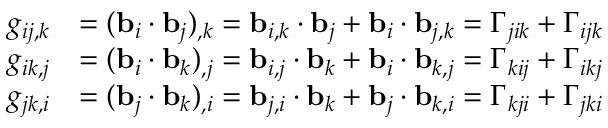Convert formula to latex. <formula><loc_0><loc_0><loc_500><loc_500>{ \begin{array} { r l } { g _ { i j , k } } & { = ( b _ { i } \cdot b _ { j } ) _ { , k } = b _ { i , k } \cdot b _ { j } + b _ { i } \cdot b _ { j , k } = \Gamma _ { j i k } + \Gamma _ { i j k } } \\ { g _ { i k , j } } & { = ( b _ { i } \cdot b _ { k } ) _ { , j } = b _ { i , j } \cdot b _ { k } + b _ { i } \cdot b _ { k , j } = \Gamma _ { k i j } + \Gamma _ { i k j } } \\ { g _ { j k , i } } & { = ( b _ { j } \cdot b _ { k } ) _ { , i } = b _ { j , i } \cdot b _ { k } + b _ { j } \cdot b _ { k , i } = \Gamma _ { k j i } + \Gamma _ { j k i } } \end{array} }</formula> 